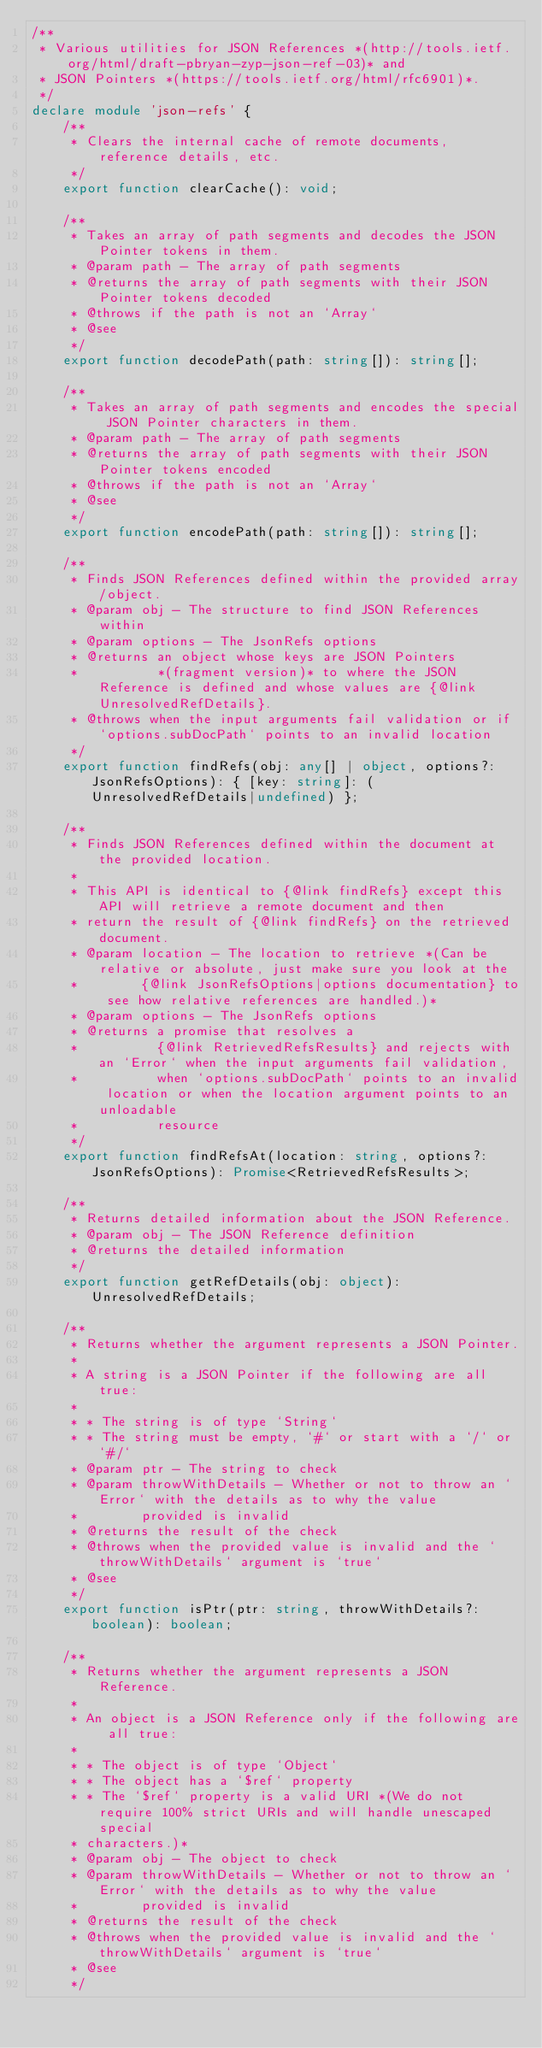Convert code to text. <code><loc_0><loc_0><loc_500><loc_500><_TypeScript_>/**
 * Various utilities for JSON References *(http://tools.ietf.org/html/draft-pbryan-zyp-json-ref-03)* and
 * JSON Pointers *(https://tools.ietf.org/html/rfc6901)*.
 */
declare module 'json-refs' {
    /**
     * Clears the internal cache of remote documents, reference details, etc.
     */
    export function clearCache(): void;

    /**
     * Takes an array of path segments and decodes the JSON Pointer tokens in them.
     * @param path - The array of path segments
     * @returns the array of path segments with their JSON Pointer tokens decoded
     * @throws if the path is not an `Array`
     * @see
     */
    export function decodePath(path: string[]): string[];

    /**
     * Takes an array of path segments and encodes the special JSON Pointer characters in them.
     * @param path - The array of path segments
     * @returns the array of path segments with their JSON Pointer tokens encoded
     * @throws if the path is not an `Array`
     * @see
     */
    export function encodePath(path: string[]): string[];

    /**
     * Finds JSON References defined within the provided array/object.
     * @param obj - The structure to find JSON References within
     * @param options - The JsonRefs options
     * @returns an object whose keys are JSON Pointers
     *          *(fragment version)* to where the JSON Reference is defined and whose values are {@link UnresolvedRefDetails}.
     * @throws when the input arguments fail validation or if `options.subDocPath` points to an invalid location
     */
    export function findRefs(obj: any[] | object, options?: JsonRefsOptions): { [key: string]: (UnresolvedRefDetails|undefined) };

    /**
     * Finds JSON References defined within the document at the provided location.
     * 
     * This API is identical to {@link findRefs} except this API will retrieve a remote document and then
     * return the result of {@link findRefs} on the retrieved document.
     * @param location - The location to retrieve *(Can be relative or absolute, just make sure you look at the
     *        {@link JsonRefsOptions|options documentation} to see how relative references are handled.)*
     * @param options - The JsonRefs options
     * @returns a promise that resolves a
     *          {@link RetrievedRefsResults} and rejects with an `Error` when the input arguments fail validation,
     *          when `options.subDocPath` points to an invalid location or when the location argument points to an unloadable
     *          resource
     */
    export function findRefsAt(location: string, options?: JsonRefsOptions): Promise<RetrievedRefsResults>;

    /**
     * Returns detailed information about the JSON Reference.
     * @param obj - The JSON Reference definition
     * @returns the detailed information
     */
    export function getRefDetails(obj: object): UnresolvedRefDetails;

    /**
     * Returns whether the argument represents a JSON Pointer.
     * 
     * A string is a JSON Pointer if the following are all true:
     * 
     * * The string is of type `String`
     * * The string must be empty, `#` or start with a `/` or `#/`
     * @param ptr - The string to check
     * @param throwWithDetails - Whether or not to throw an `Error` with the details as to why the value
     *        provided is invalid
     * @returns the result of the check
     * @throws when the provided value is invalid and the `throwWithDetails` argument is `true`
     * @see
     */
    export function isPtr(ptr: string, throwWithDetails?: boolean): boolean;

    /**
     * Returns whether the argument represents a JSON Reference.
     * 
     * An object is a JSON Reference only if the following are all true:
     * 
     * * The object is of type `Object`
     * * The object has a `$ref` property
     * * The `$ref` property is a valid URI *(We do not require 100% strict URIs and will handle unescaped special
     * characters.)*
     * @param obj - The object to check
     * @param throwWithDetails - Whether or not to throw an `Error` with the details as to why the value
     *        provided is invalid
     * @returns the result of the check
     * @throws when the provided value is invalid and the `throwWithDetails` argument is `true`
     * @see
     */</code> 